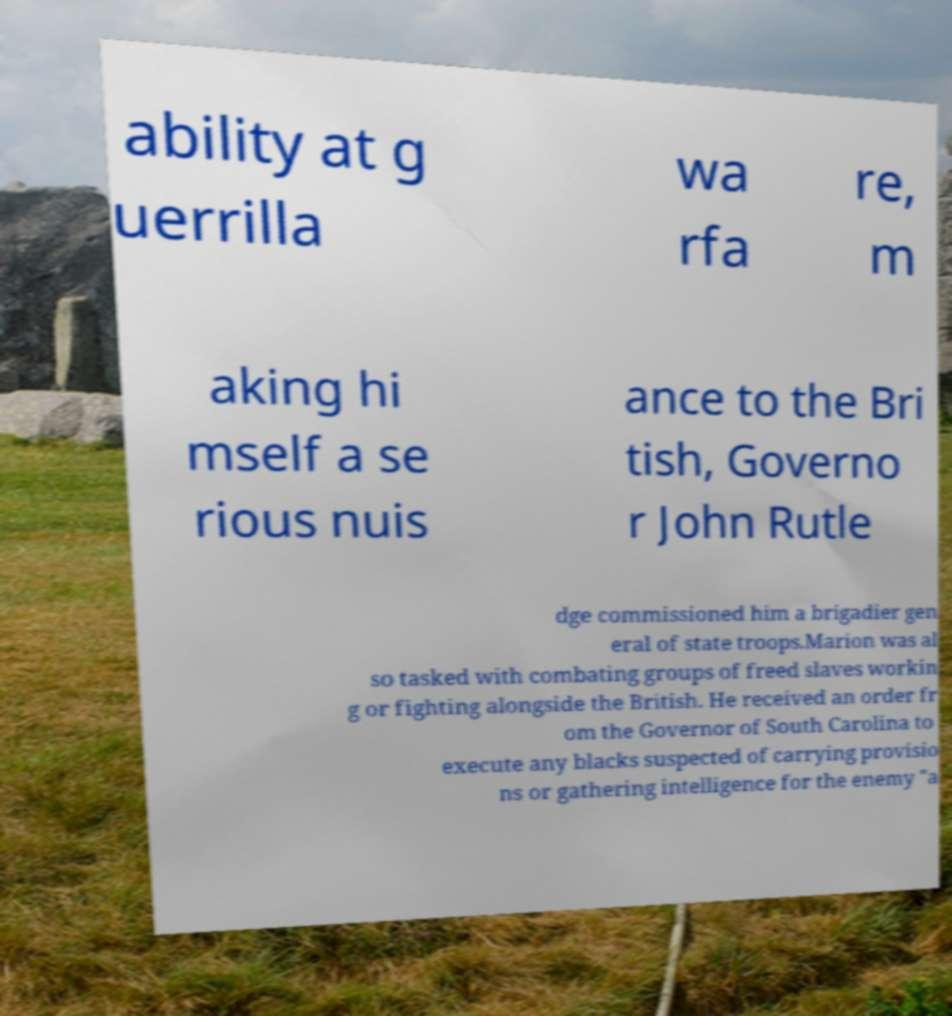Can you read and provide the text displayed in the image?This photo seems to have some interesting text. Can you extract and type it out for me? ability at g uerrilla wa rfa re, m aking hi mself a se rious nuis ance to the Bri tish, Governo r John Rutle dge commissioned him a brigadier gen eral of state troops.Marion was al so tasked with combating groups of freed slaves workin g or fighting alongside the British. He received an order fr om the Governor of South Carolina to execute any blacks suspected of carrying provisio ns or gathering intelligence for the enemy "a 